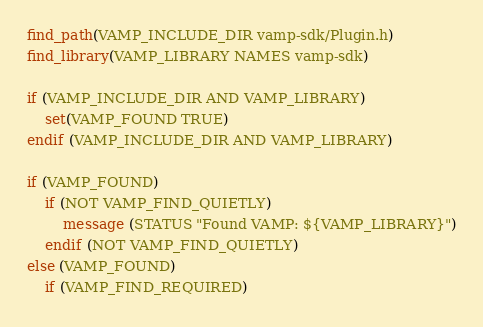Convert code to text. <code><loc_0><loc_0><loc_500><loc_500><_CMake_>find_path(VAMP_INCLUDE_DIR vamp-sdk/Plugin.h)
find_library(VAMP_LIBRARY NAMES vamp-sdk)

if (VAMP_INCLUDE_DIR AND VAMP_LIBRARY)
	set(VAMP_FOUND TRUE)
endif (VAMP_INCLUDE_DIR AND VAMP_LIBRARY)

if (VAMP_FOUND)
	if (NOT VAMP_FIND_QUIETLY)
		message (STATUS "Found VAMP: ${VAMP_LIBRARY}")
	endif (NOT VAMP_FIND_QUIETLY)
else (VAMP_FOUND)
	if (VAMP_FIND_REQUIRED)</code> 